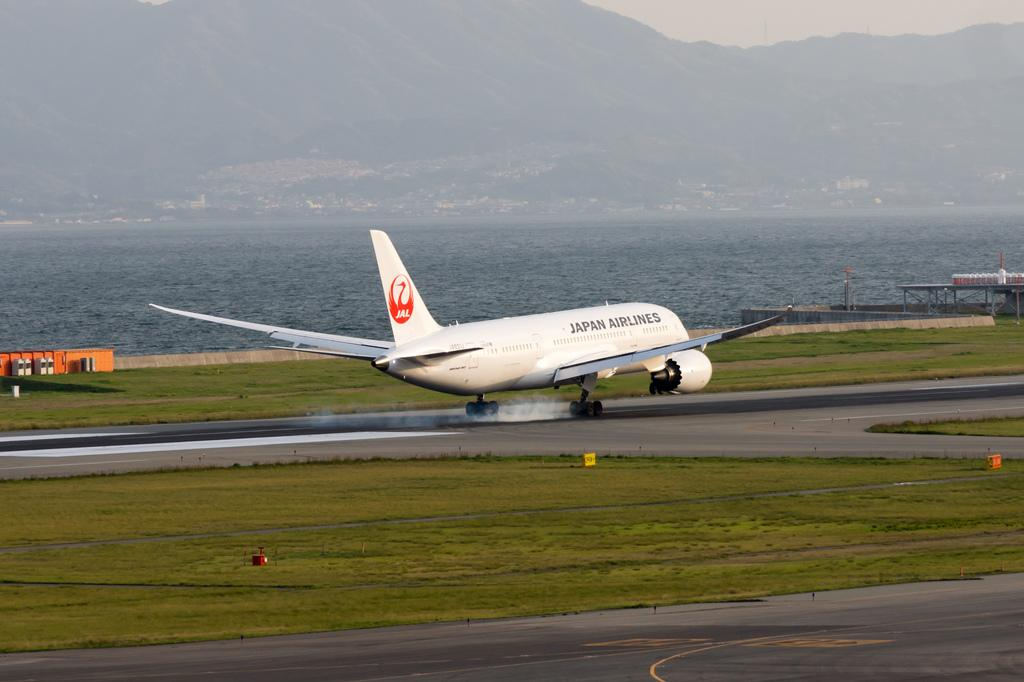<image>
Provide a brief description of the given image. An airplane from Japan Airlines landing on the runway 